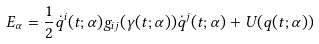Convert formula to latex. <formula><loc_0><loc_0><loc_500><loc_500>E _ { \alpha } = \frac { 1 } { 2 } \dot { q } ^ { i } ( t ; \alpha ) g _ { i j } ( \gamma ( t ; \alpha ) ) \dot { q } ^ { j } ( t ; \alpha ) + U ( q ( t ; \alpha ) )</formula> 